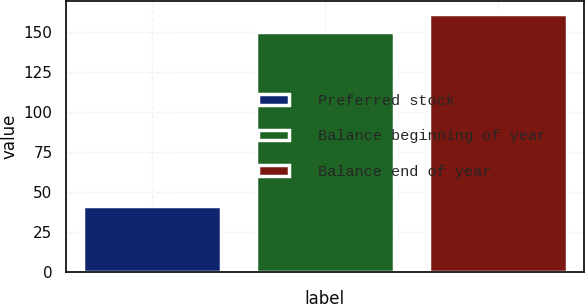<chart> <loc_0><loc_0><loc_500><loc_500><bar_chart><fcel>Preferred stock<fcel>Balance beginning of year<fcel>Balance end of year<nl><fcel>41<fcel>150<fcel>161.6<nl></chart> 